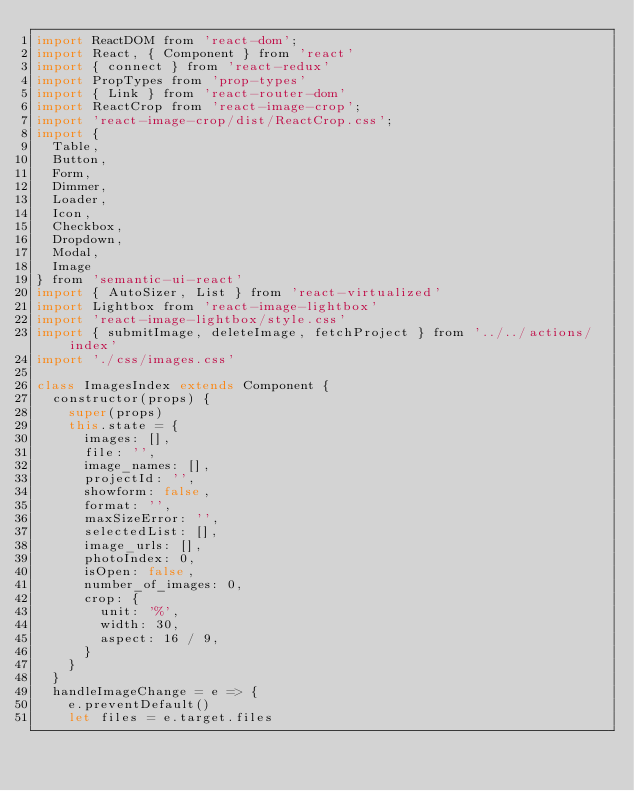<code> <loc_0><loc_0><loc_500><loc_500><_JavaScript_>import ReactDOM from 'react-dom';
import React, { Component } from 'react'
import { connect } from 'react-redux'
import PropTypes from 'prop-types'
import { Link } from 'react-router-dom'
import ReactCrop from 'react-image-crop';
import 'react-image-crop/dist/ReactCrop.css';
import {
  Table,
  Button,
  Form,
  Dimmer,
  Loader,
  Icon,
  Checkbox,
  Dropdown,
  Modal,
  Image
} from 'semantic-ui-react'
import { AutoSizer, List } from 'react-virtualized'
import Lightbox from 'react-image-lightbox'
import 'react-image-lightbox/style.css'
import { submitImage, deleteImage, fetchProject } from '../../actions/index'
import './css/images.css'

class ImagesIndex extends Component {
  constructor(props) {
    super(props)
    this.state = {
      images: [],
      file: '',
      image_names: [],
      projectId: '',
      showform: false,
      format: '',
      maxSizeError: '',
      selectedList: [],
      image_urls: [],
      photoIndex: 0,
      isOpen: false,
      number_of_images: 0,
      crop: {
        unit: '%',
        width: 30,
        aspect: 16 / 9,
      }
    }
  }
  handleImageChange = e => {
    e.preventDefault()
    let files = e.target.files</code> 